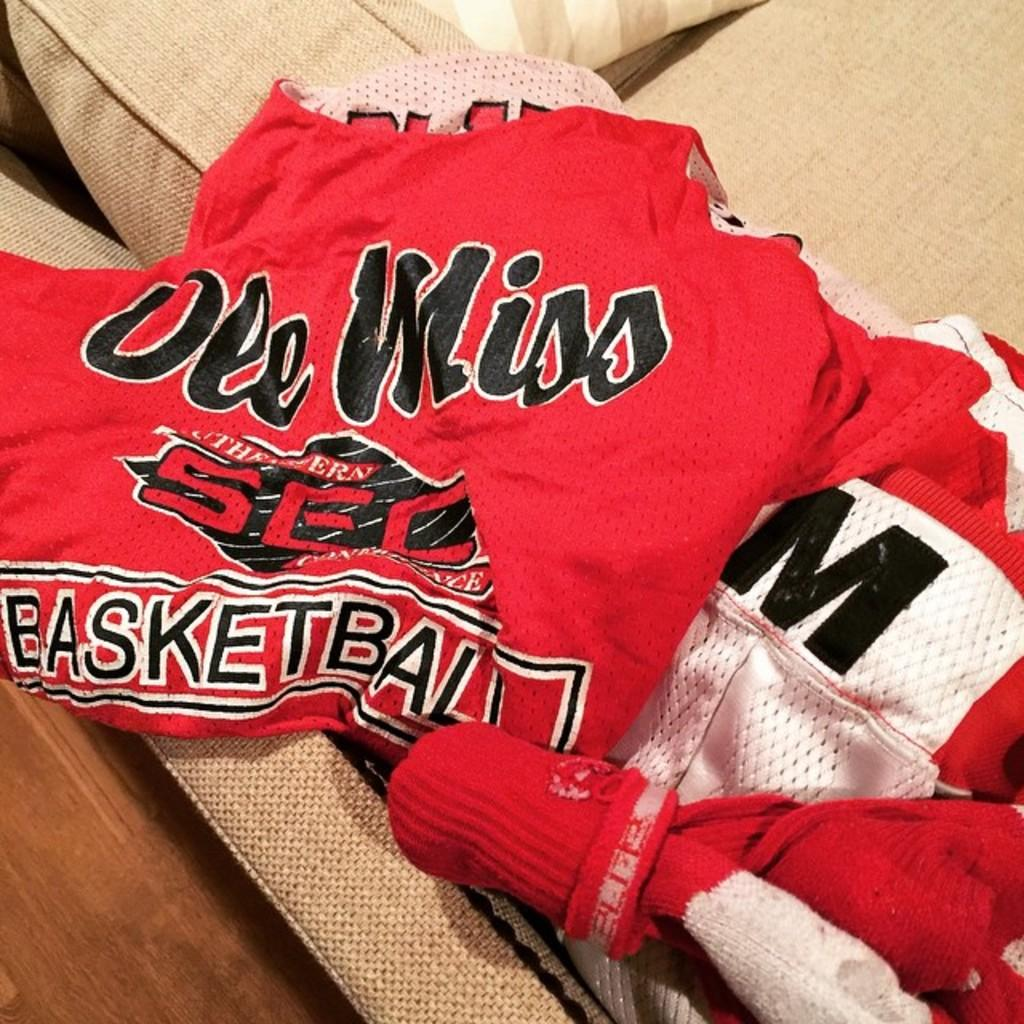<image>
Offer a succinct explanation of the picture presented. An Ole Miss Basketball jersey and a pair of socks are on a sofa. 